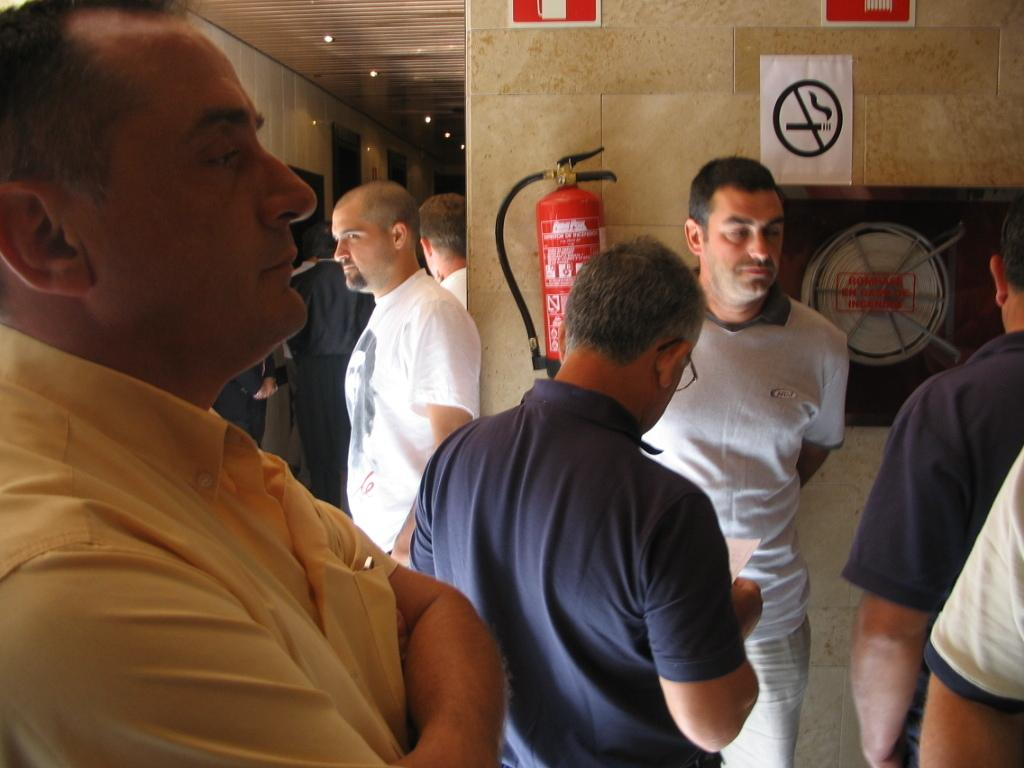Who are the people in the image? The facts do not provide information about the identities of the people in the image. What safety equipment can be seen in the image? There is a wall with a fire extinguisher in the image. What is attached to the wall in the image? There is an object on the wall, but the facts do not specify what it is. What type of decorations are present in the image? There are posters and frames in the image. What part of the building can be seen in the image? There is a roof visible in the image. What lighting features are present on the roof? There are lights on the roof. What is the name of the cobweb in the image? There is no cobweb present in the image. Who has the authority to remove the object on the wall in the image? The facts do not provide information about the authority to remove the object on the wall in the image. 